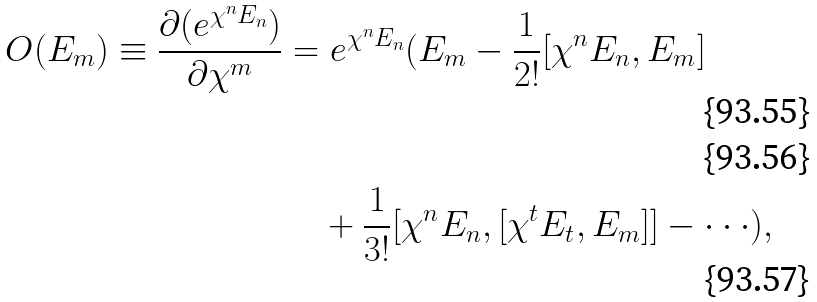Convert formula to latex. <formula><loc_0><loc_0><loc_500><loc_500>O ( E _ { m } ) \equiv \frac { \partial ( e ^ { \chi ^ { n } E _ { n } } ) } { \partial \chi ^ { m } } & = e ^ { \chi ^ { n } E _ { n } } ( E _ { m } - \frac { 1 } { 2 ! } [ \chi ^ { n } E _ { n } , E _ { m } ] \\ \\ & \quad + \frac { 1 } { 3 ! } [ \chi ^ { n } E _ { n } , [ \chi ^ { t } E _ { t } , E _ { m } ] ] - \cdot \cdot \cdot ) ,</formula> 